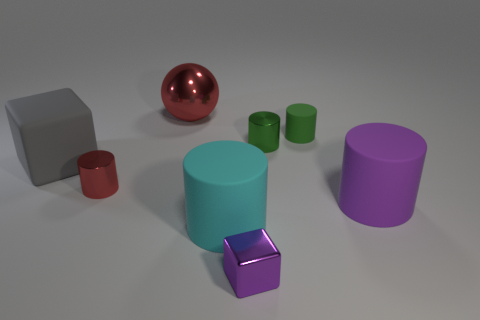Subtract all cyan cylinders. How many cylinders are left? 4 Add 2 red metal things. How many objects exist? 10 Subtract all green cylinders. How many cylinders are left? 3 Subtract all cylinders. How many objects are left? 3 Add 5 tiny rubber cylinders. How many tiny rubber cylinders are left? 6 Add 1 large cylinders. How many large cylinders exist? 3 Subtract 1 red cylinders. How many objects are left? 7 Subtract 1 spheres. How many spheres are left? 0 Subtract all gray blocks. Subtract all brown spheres. How many blocks are left? 1 Subtract all red cylinders. How many purple cubes are left? 1 